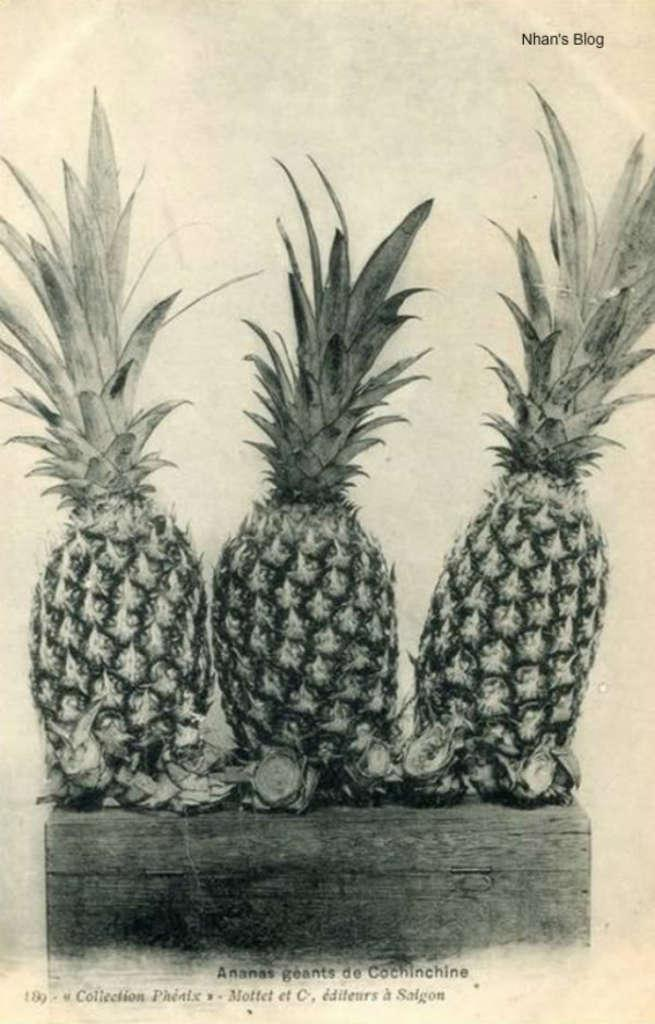What type of image is being described? The image is a poster. What is the main subject of the poster? There are three pineapples in the image. Where are the pineapples placed? The pineapples are placed on a wooden table. Can you see any icicles forming on the pineapples in the image? There are no icicles present in the image, as the setting does not suggest cold temperatures. 